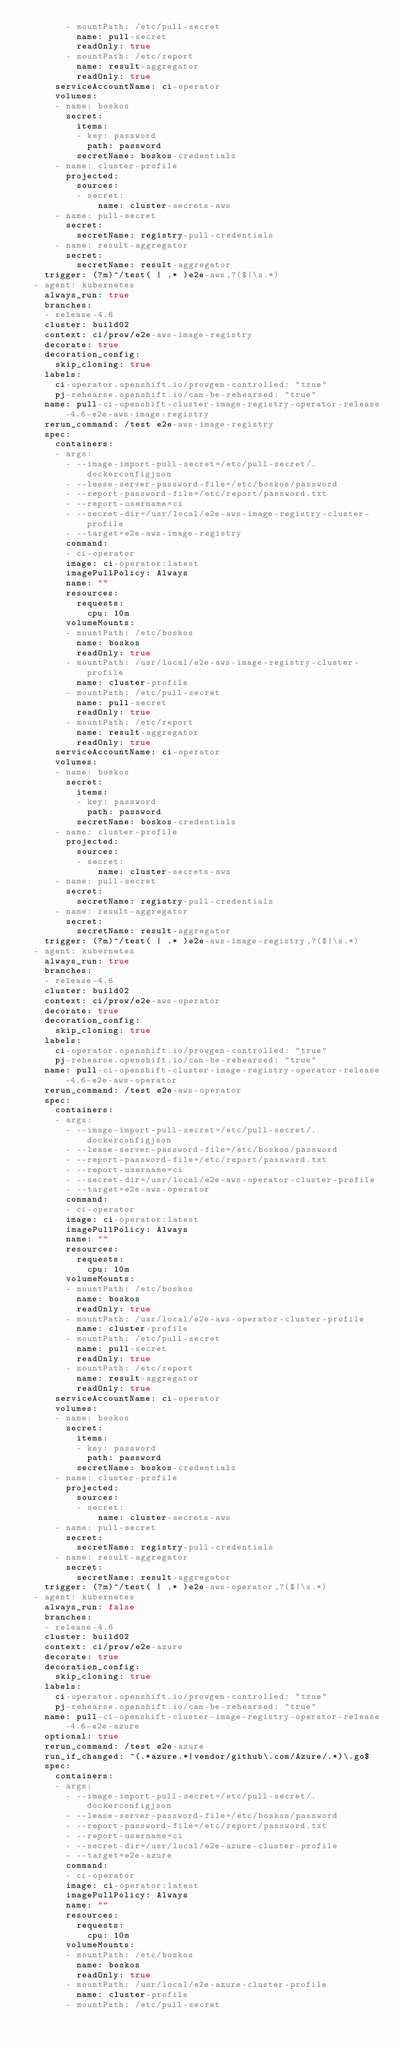<code> <loc_0><loc_0><loc_500><loc_500><_YAML_>        - mountPath: /etc/pull-secret
          name: pull-secret
          readOnly: true
        - mountPath: /etc/report
          name: result-aggregator
          readOnly: true
      serviceAccountName: ci-operator
      volumes:
      - name: boskos
        secret:
          items:
          - key: password
            path: password
          secretName: boskos-credentials
      - name: cluster-profile
        projected:
          sources:
          - secret:
              name: cluster-secrets-aws
      - name: pull-secret
        secret:
          secretName: registry-pull-credentials
      - name: result-aggregator
        secret:
          secretName: result-aggregator
    trigger: (?m)^/test( | .* )e2e-aws,?($|\s.*)
  - agent: kubernetes
    always_run: true
    branches:
    - release-4.6
    cluster: build02
    context: ci/prow/e2e-aws-image-registry
    decorate: true
    decoration_config:
      skip_cloning: true
    labels:
      ci-operator.openshift.io/prowgen-controlled: "true"
      pj-rehearse.openshift.io/can-be-rehearsed: "true"
    name: pull-ci-openshift-cluster-image-registry-operator-release-4.6-e2e-aws-image-registry
    rerun_command: /test e2e-aws-image-registry
    spec:
      containers:
      - args:
        - --image-import-pull-secret=/etc/pull-secret/.dockerconfigjson
        - --lease-server-password-file=/etc/boskos/password
        - --report-password-file=/etc/report/password.txt
        - --report-username=ci
        - --secret-dir=/usr/local/e2e-aws-image-registry-cluster-profile
        - --target=e2e-aws-image-registry
        command:
        - ci-operator
        image: ci-operator:latest
        imagePullPolicy: Always
        name: ""
        resources:
          requests:
            cpu: 10m
        volumeMounts:
        - mountPath: /etc/boskos
          name: boskos
          readOnly: true
        - mountPath: /usr/local/e2e-aws-image-registry-cluster-profile
          name: cluster-profile
        - mountPath: /etc/pull-secret
          name: pull-secret
          readOnly: true
        - mountPath: /etc/report
          name: result-aggregator
          readOnly: true
      serviceAccountName: ci-operator
      volumes:
      - name: boskos
        secret:
          items:
          - key: password
            path: password
          secretName: boskos-credentials
      - name: cluster-profile
        projected:
          sources:
          - secret:
              name: cluster-secrets-aws
      - name: pull-secret
        secret:
          secretName: registry-pull-credentials
      - name: result-aggregator
        secret:
          secretName: result-aggregator
    trigger: (?m)^/test( | .* )e2e-aws-image-registry,?($|\s.*)
  - agent: kubernetes
    always_run: true
    branches:
    - release-4.6
    cluster: build02
    context: ci/prow/e2e-aws-operator
    decorate: true
    decoration_config:
      skip_cloning: true
    labels:
      ci-operator.openshift.io/prowgen-controlled: "true"
      pj-rehearse.openshift.io/can-be-rehearsed: "true"
    name: pull-ci-openshift-cluster-image-registry-operator-release-4.6-e2e-aws-operator
    rerun_command: /test e2e-aws-operator
    spec:
      containers:
      - args:
        - --image-import-pull-secret=/etc/pull-secret/.dockerconfigjson
        - --lease-server-password-file=/etc/boskos/password
        - --report-password-file=/etc/report/password.txt
        - --report-username=ci
        - --secret-dir=/usr/local/e2e-aws-operator-cluster-profile
        - --target=e2e-aws-operator
        command:
        - ci-operator
        image: ci-operator:latest
        imagePullPolicy: Always
        name: ""
        resources:
          requests:
            cpu: 10m
        volumeMounts:
        - mountPath: /etc/boskos
          name: boskos
          readOnly: true
        - mountPath: /usr/local/e2e-aws-operator-cluster-profile
          name: cluster-profile
        - mountPath: /etc/pull-secret
          name: pull-secret
          readOnly: true
        - mountPath: /etc/report
          name: result-aggregator
          readOnly: true
      serviceAccountName: ci-operator
      volumes:
      - name: boskos
        secret:
          items:
          - key: password
            path: password
          secretName: boskos-credentials
      - name: cluster-profile
        projected:
          sources:
          - secret:
              name: cluster-secrets-aws
      - name: pull-secret
        secret:
          secretName: registry-pull-credentials
      - name: result-aggregator
        secret:
          secretName: result-aggregator
    trigger: (?m)^/test( | .* )e2e-aws-operator,?($|\s.*)
  - agent: kubernetes
    always_run: false
    branches:
    - release-4.6
    cluster: build02
    context: ci/prow/e2e-azure
    decorate: true
    decoration_config:
      skip_cloning: true
    labels:
      ci-operator.openshift.io/prowgen-controlled: "true"
      pj-rehearse.openshift.io/can-be-rehearsed: "true"
    name: pull-ci-openshift-cluster-image-registry-operator-release-4.6-e2e-azure
    optional: true
    rerun_command: /test e2e-azure
    run_if_changed: ^(.*azure.*|vendor/github\.com/Azure/.*)\.go$
    spec:
      containers:
      - args:
        - --image-import-pull-secret=/etc/pull-secret/.dockerconfigjson
        - --lease-server-password-file=/etc/boskos/password
        - --report-password-file=/etc/report/password.txt
        - --report-username=ci
        - --secret-dir=/usr/local/e2e-azure-cluster-profile
        - --target=e2e-azure
        command:
        - ci-operator
        image: ci-operator:latest
        imagePullPolicy: Always
        name: ""
        resources:
          requests:
            cpu: 10m
        volumeMounts:
        - mountPath: /etc/boskos
          name: boskos
          readOnly: true
        - mountPath: /usr/local/e2e-azure-cluster-profile
          name: cluster-profile
        - mountPath: /etc/pull-secret</code> 